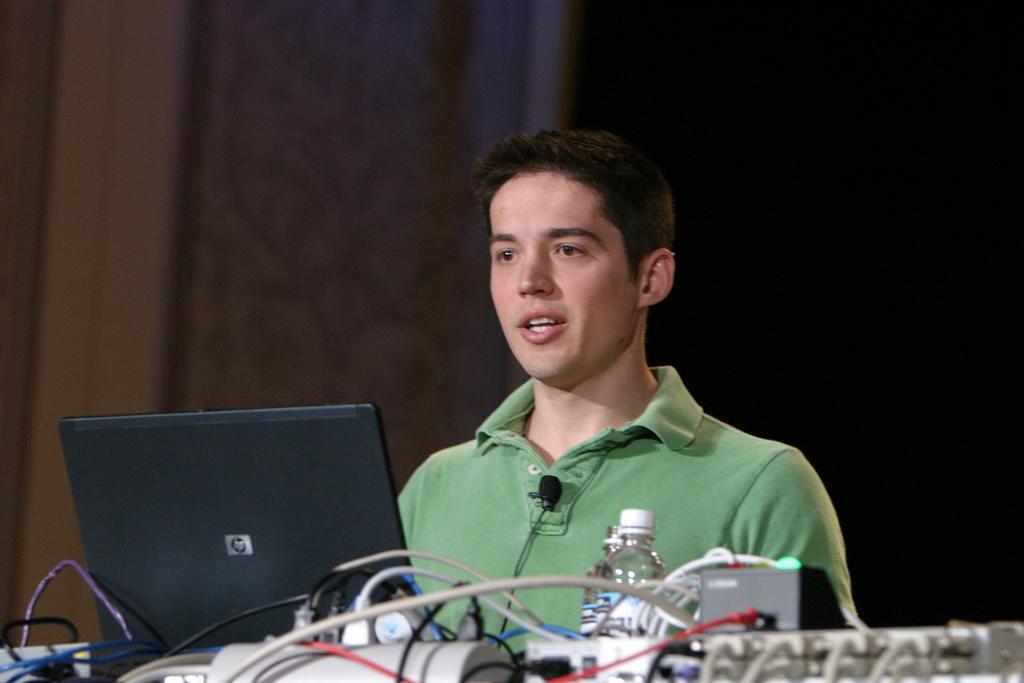Can you describe this image briefly? In this image there is a person, in front of the person there is a laptop, bottle and a few other objects with cables. The background is dark. 